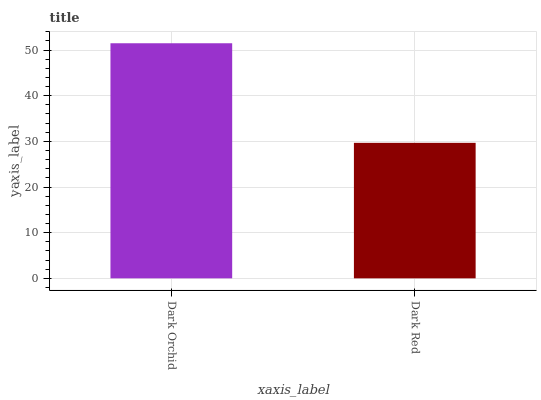Is Dark Red the minimum?
Answer yes or no. Yes. Is Dark Orchid the maximum?
Answer yes or no. Yes. Is Dark Red the maximum?
Answer yes or no. No. Is Dark Orchid greater than Dark Red?
Answer yes or no. Yes. Is Dark Red less than Dark Orchid?
Answer yes or no. Yes. Is Dark Red greater than Dark Orchid?
Answer yes or no. No. Is Dark Orchid less than Dark Red?
Answer yes or no. No. Is Dark Orchid the high median?
Answer yes or no. Yes. Is Dark Red the low median?
Answer yes or no. Yes. Is Dark Red the high median?
Answer yes or no. No. Is Dark Orchid the low median?
Answer yes or no. No. 